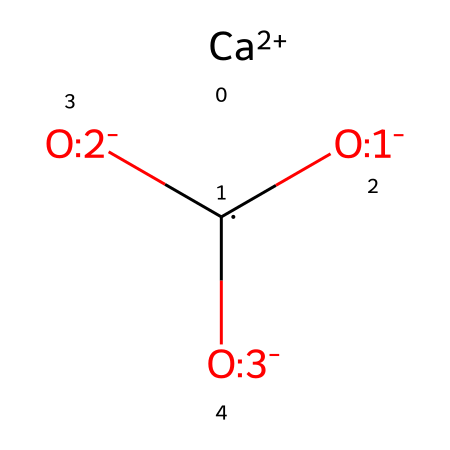What is the name of this chemical? The molecular composition represented by the SMILES indicates that it consists of calcium and carbonate ions, which together form calcium carbonate.
Answer: calcium carbonate How many oxygen atoms are in the structure? The chemical structure includes three oxygen atoms indicated by [O-:1], [O-:2], and [O-:3].
Answer: three What charge does the calcium ion carry? The structure shows [Ca+2], which indicates that the calcium ion has a charge of +2.
Answer: +2 What type of compound is calcium carbonate? Based on the presence of the carbonate ion (CO3) and the metal calcium, this compound is classified as a salt.
Answer: salt How many total atoms are present in the structure? The molecule consists of one calcium atom, one carbon atom, and three oxygen atoms, totaling five atoms.
Answer: five Does this compound readily dissolve in water? Calcium carbonate is generally considered insoluble in water, but it can dissolve in acidic conditions, indicating it has limited solubility.
Answer: limited solubility What functional group is present in calcium carbonate? The carbonate ion (CO3) functions as the functional group in this compound, which is characteristic of bases as it can accept protons.
Answer: carbonate ion 